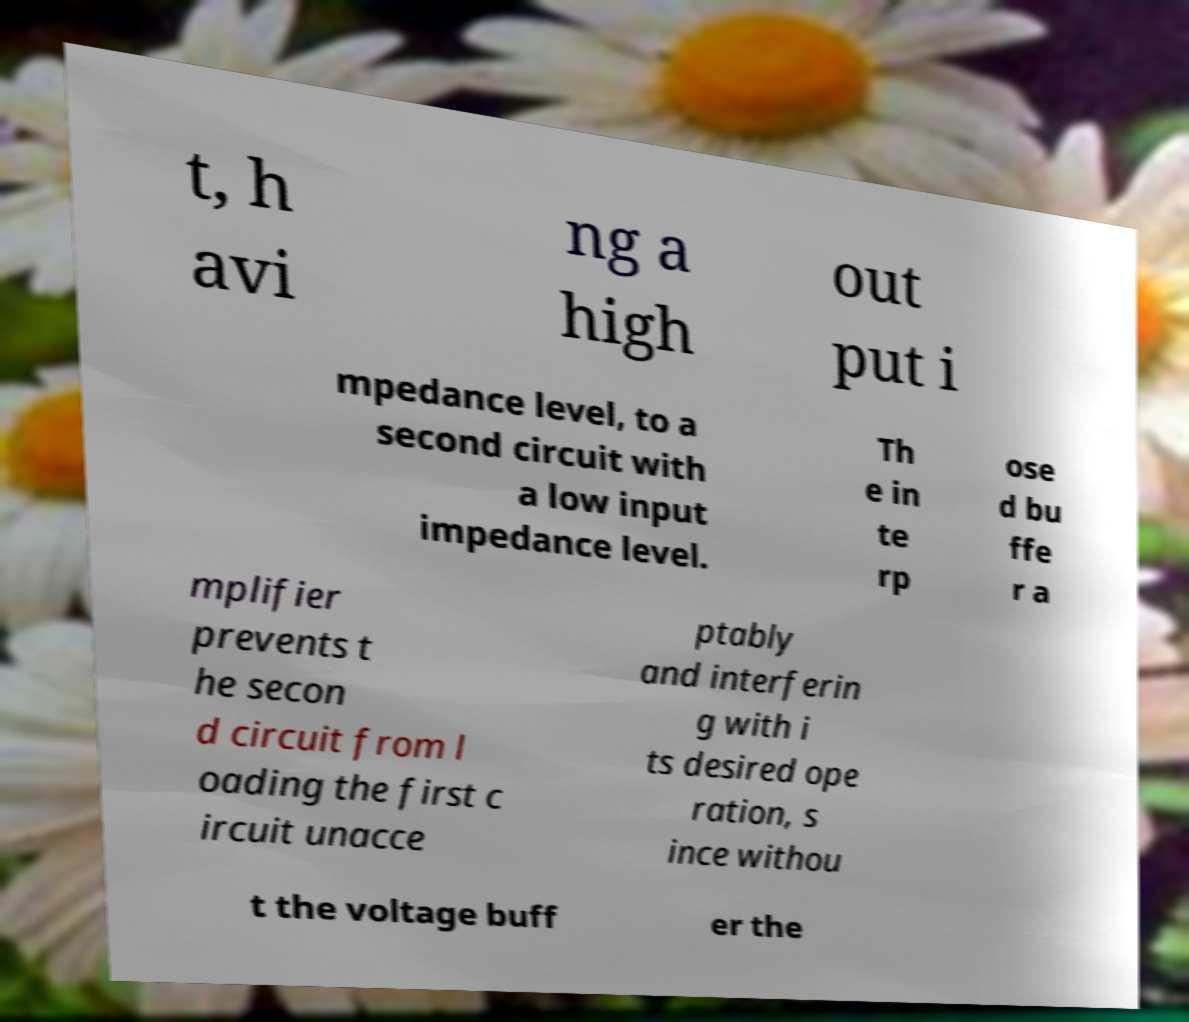For documentation purposes, I need the text within this image transcribed. Could you provide that? t, h avi ng a high out put i mpedance level, to a second circuit with a low input impedance level. Th e in te rp ose d bu ffe r a mplifier prevents t he secon d circuit from l oading the first c ircuit unacce ptably and interferin g with i ts desired ope ration, s ince withou t the voltage buff er the 